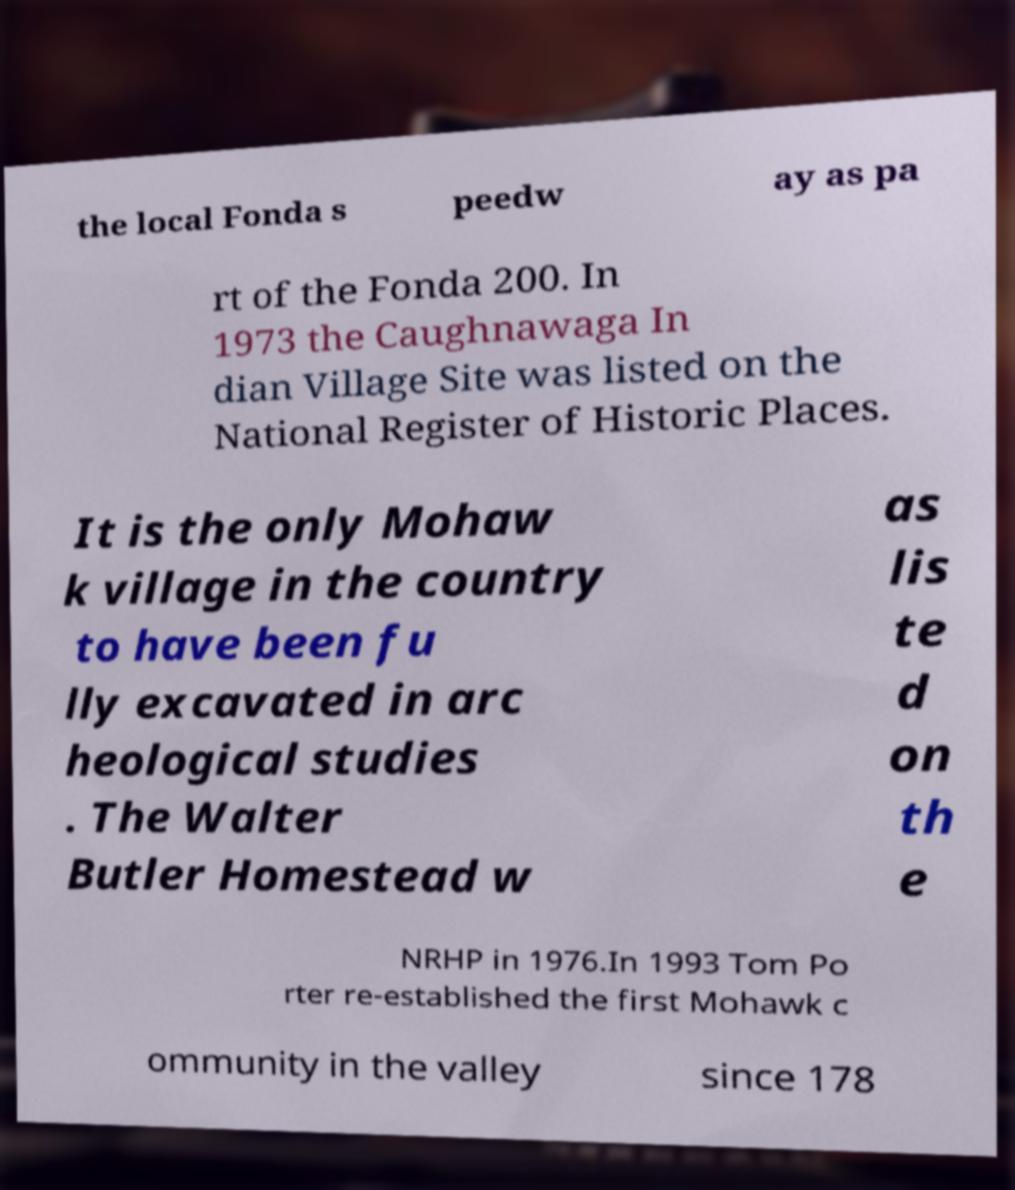For documentation purposes, I need the text within this image transcribed. Could you provide that? the local Fonda s peedw ay as pa rt of the Fonda 200. In 1973 the Caughnawaga In dian Village Site was listed on the National Register of Historic Places. It is the only Mohaw k village in the country to have been fu lly excavated in arc heological studies . The Walter Butler Homestead w as lis te d on th e NRHP in 1976.In 1993 Tom Po rter re-established the first Mohawk c ommunity in the valley since 178 